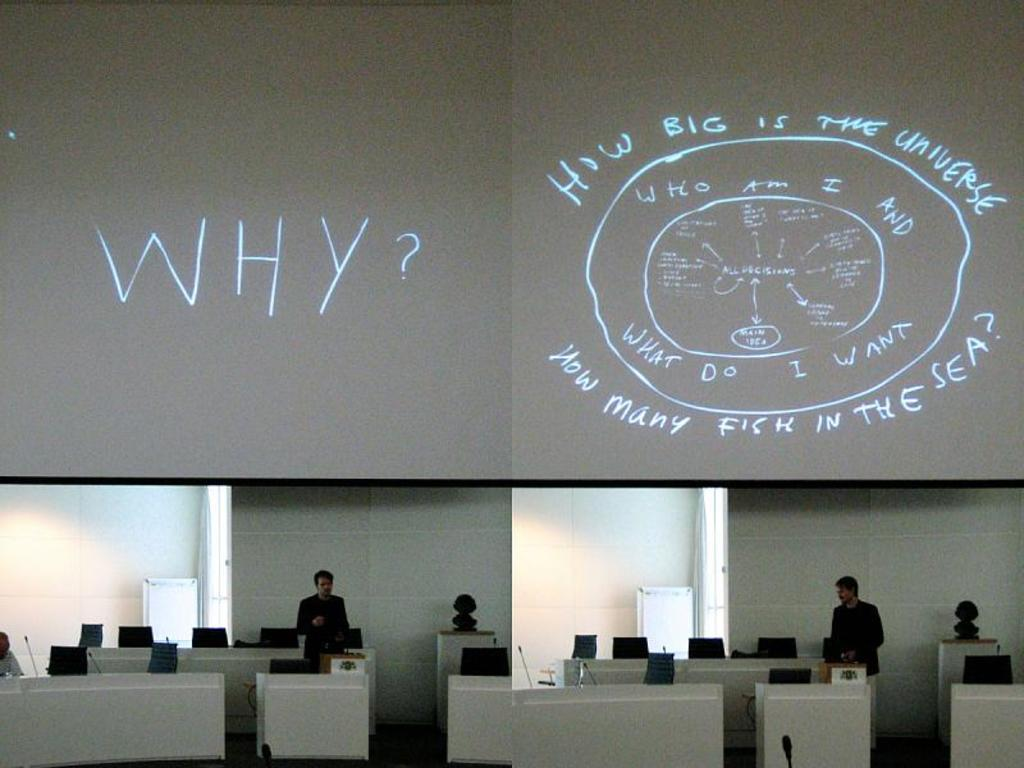Who or what is present in the image? There are people in the image. What are the people wearing? The people are wearing black dress. What type of furniture is in the image? There are chairs in the image. What equipment is visible in the image? There are microphones in the image. What can be seen in the background of the image? There is text visible in the background of the image. What type of thread is being used to sew the cracker in the image? There is no thread or cracker present in the image. 